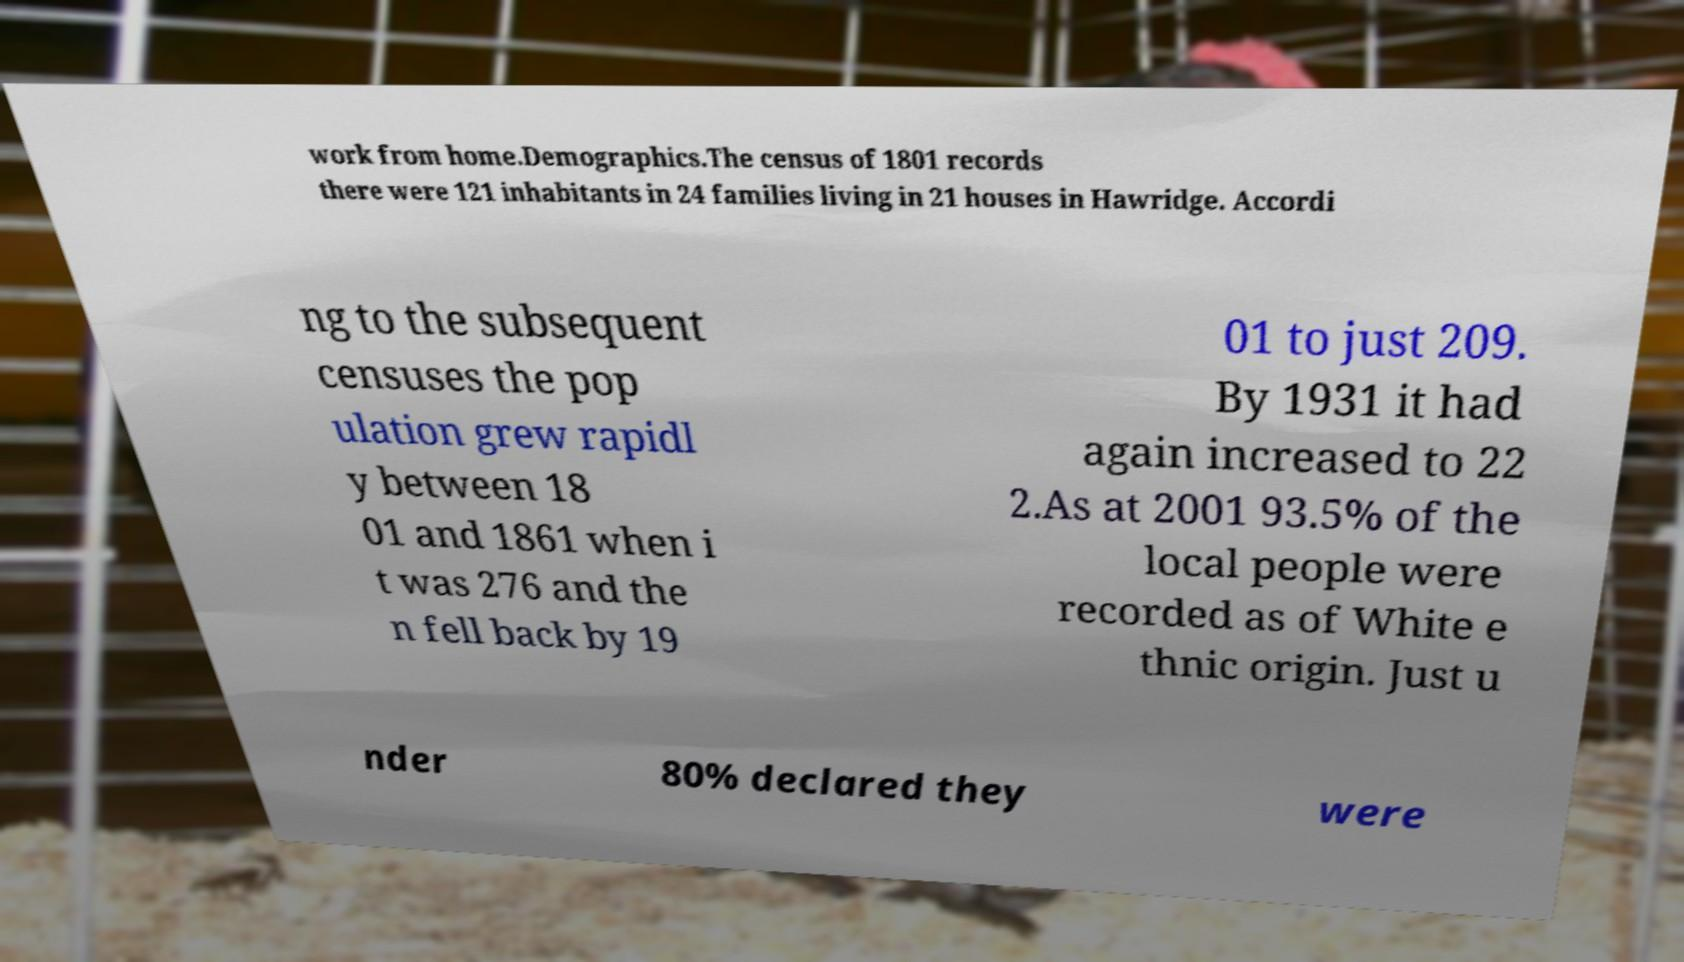Can you accurately transcribe the text from the provided image for me? work from home.Demographics.The census of 1801 records there were 121 inhabitants in 24 families living in 21 houses in Hawridge. Accordi ng to the subsequent censuses the pop ulation grew rapidl y between 18 01 and 1861 when i t was 276 and the n fell back by 19 01 to just 209. By 1931 it had again increased to 22 2.As at 2001 93.5% of the local people were recorded as of White e thnic origin. Just u nder 80% declared they were 